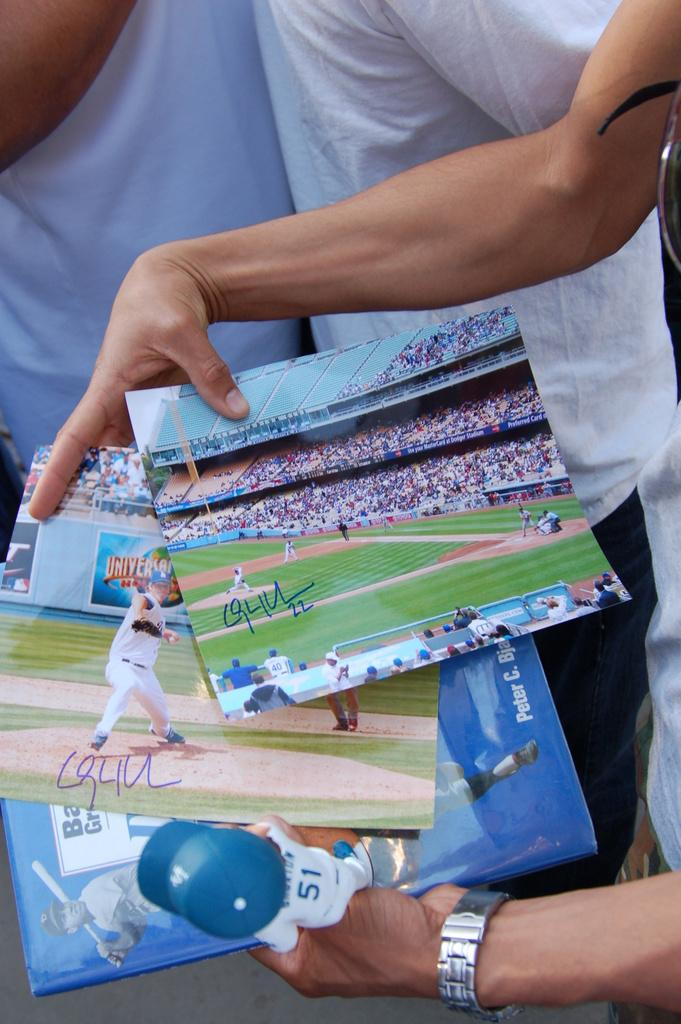What is the main subject of the image? There is a person in the image whose face is not visible. What is the person holding in their hand? The person is holding photos in their hand. Can you describe the other people visible in the image? There are two other persons visible in the background of the image, and they are wearing clothes. Where is the pear located in the image? There is no pear present in the image. Is there a faucet visible in the image? No, there is no faucet visible in the image. 